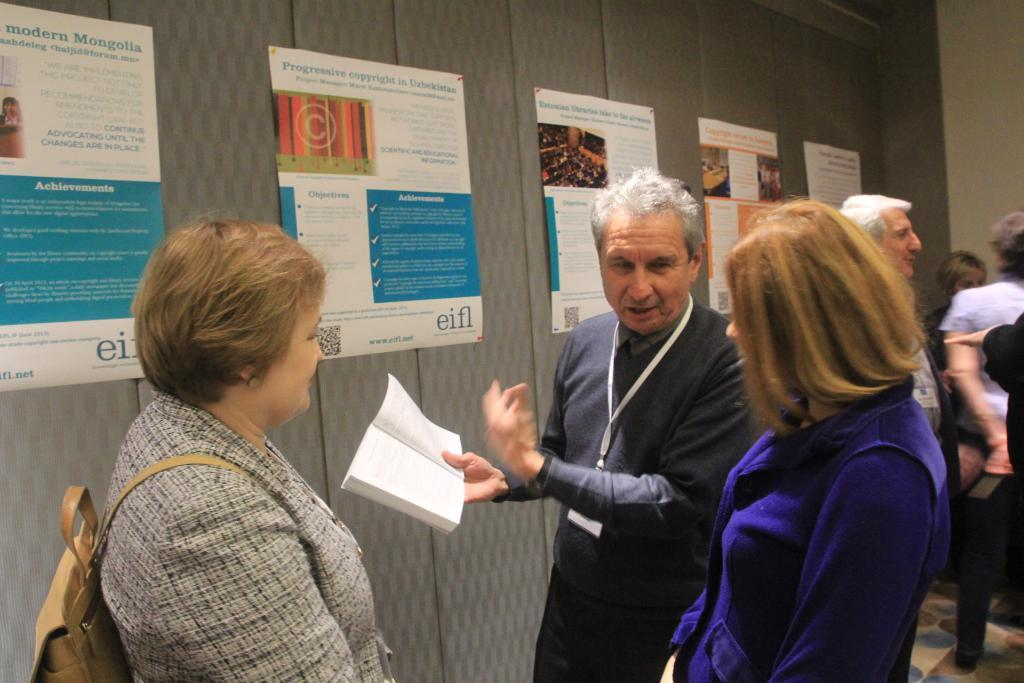Who or what can be seen in the image? There are people in the image. What are the people wearing? The people are wearing clothes. Can you describe the action or activity be observed in the image? Yes, there is a person in the middle of the image holding a book with his hand. What can be seen on the wall in the image? There are posters on the wall. What type of brake can be seen on the sun in the image? There is no sun or brake present in the image. What is the mist doing in the image? There is no mist present in the image. 